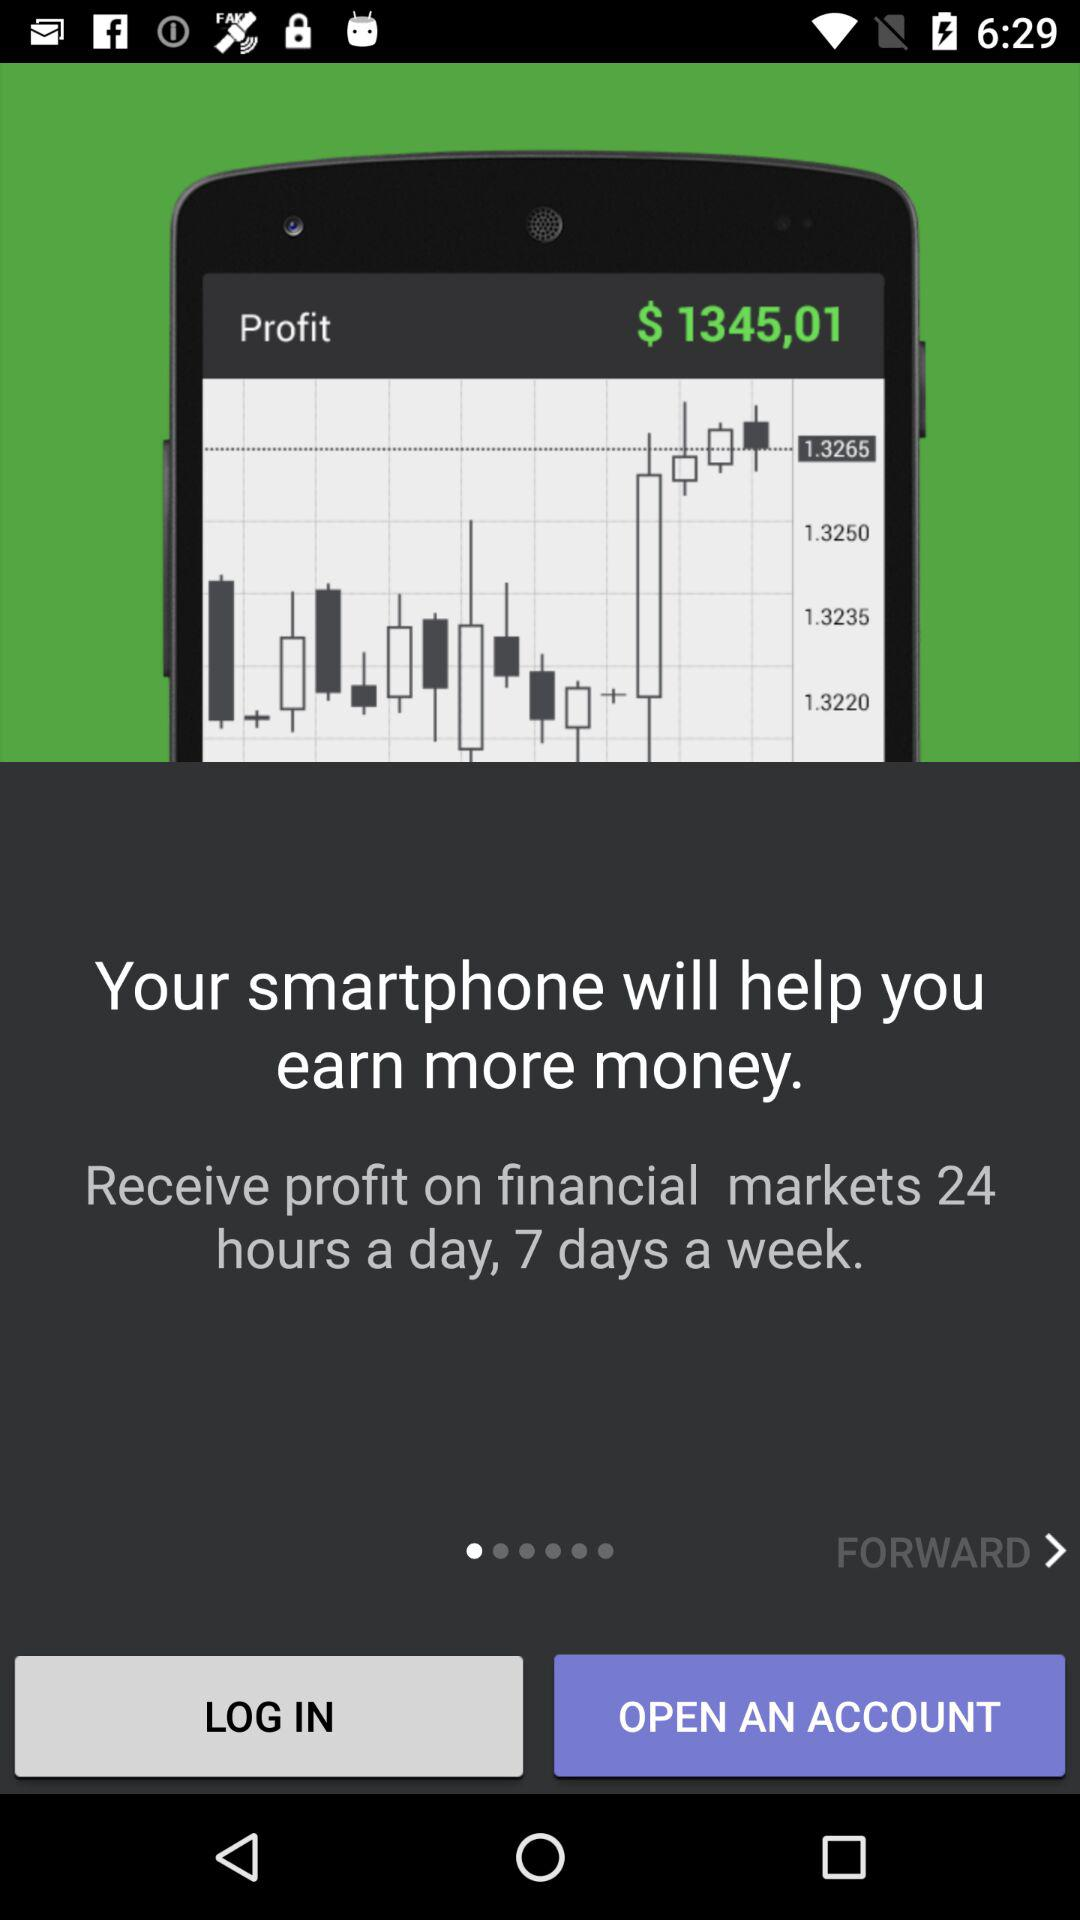What is the timing of receiving profit on financial markets? The timing is 24 hours a day, 7 days a week. 